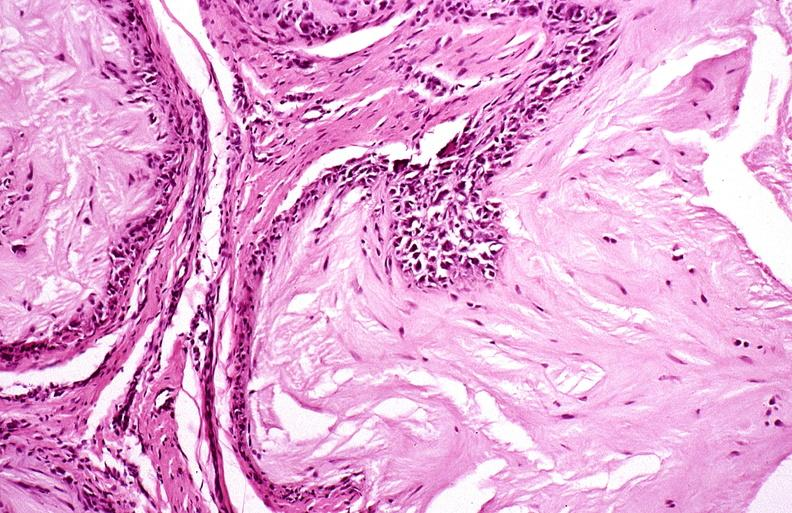what does this image show?
Answer the question using a single word or phrase. Gout 